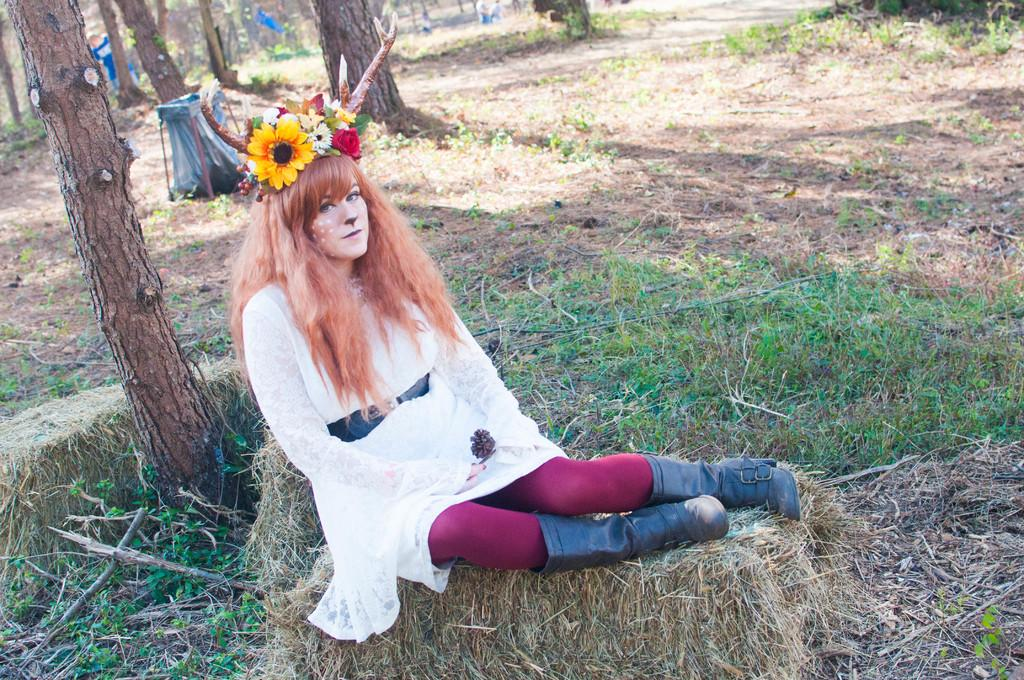Who is the main subject in the image? There is a woman in the image. What is the woman doing in the image? The woman is sitting on the grass. What can be seen on the left side of the image? There are trees on the left side of the image. How far away is the toad from the woman in the image? There is no toad present in the image, so it is not possible to determine the distance between the woman and a toad. 